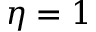Convert formula to latex. <formula><loc_0><loc_0><loc_500><loc_500>\eta = 1</formula> 